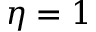Convert formula to latex. <formula><loc_0><loc_0><loc_500><loc_500>\eta = 1</formula> 